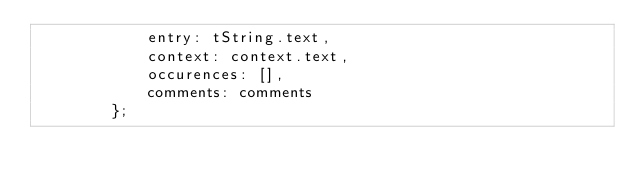Convert code to text. <code><loc_0><loc_0><loc_500><loc_500><_JavaScript_>            entry: tString.text,
            context: context.text,
            occurences: [],
            comments: comments
        };</code> 